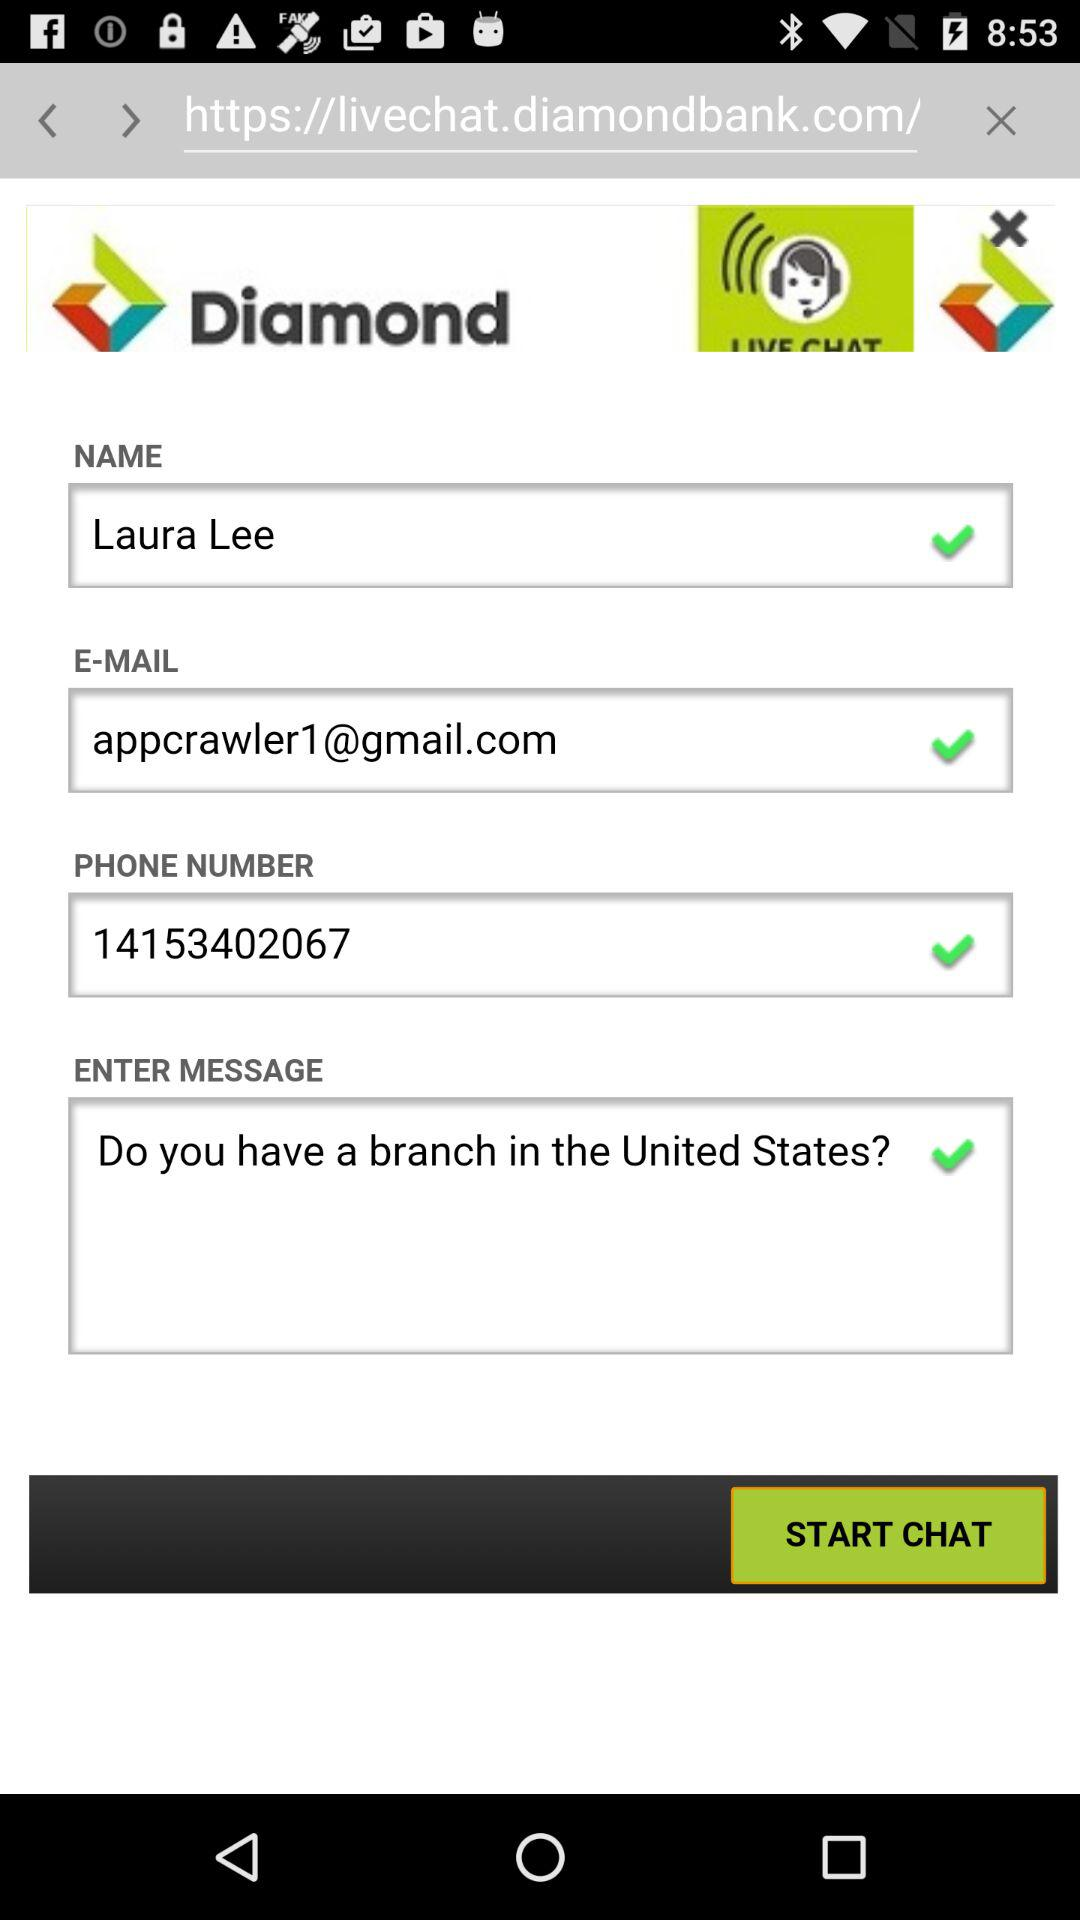What is the name of the application? The name of the application is "Diamond". 